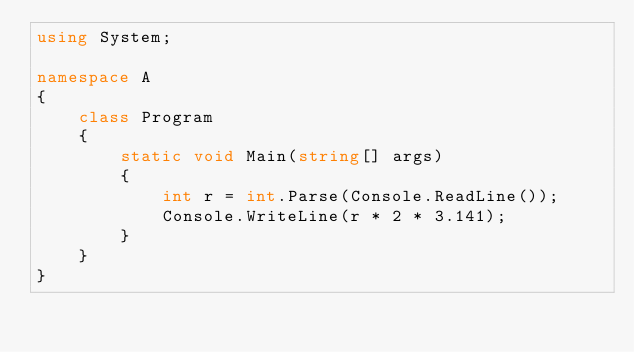Convert code to text. <code><loc_0><loc_0><loc_500><loc_500><_C#_>using System;

namespace A
{
    class Program
    {
        static void Main(string[] args)
        {
            int r = int.Parse(Console.ReadLine());
            Console.WriteLine(r * 2 * 3.141);
        }
    }
}
</code> 